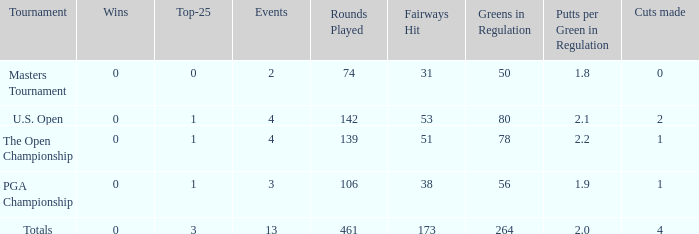How many cuts made in the tournament he played 13 times? None. 